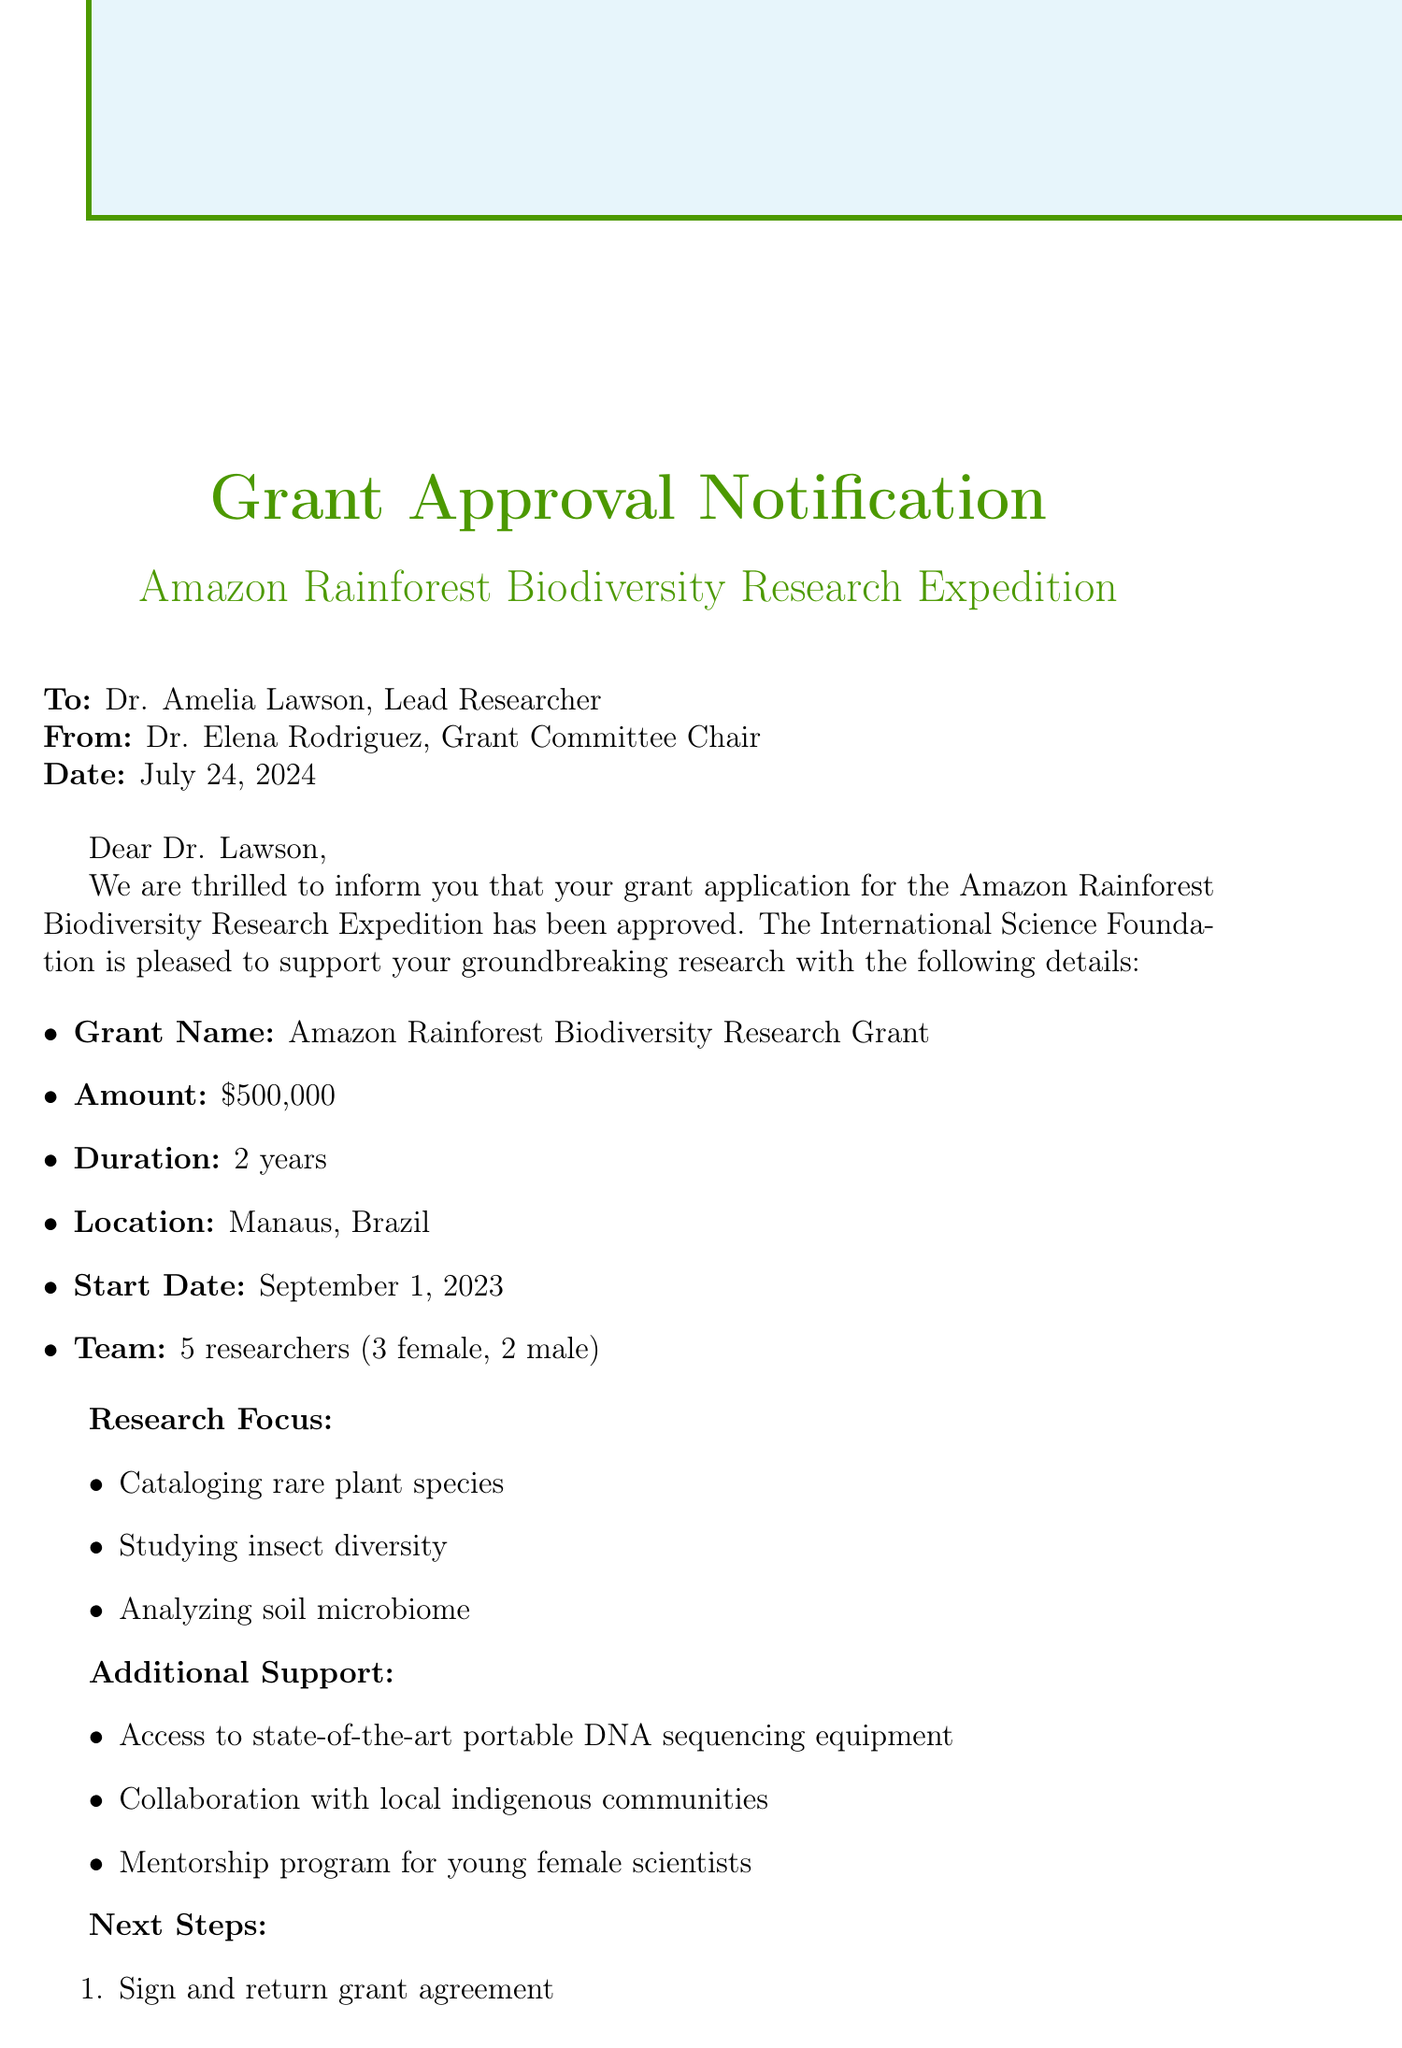What is the name of the grant? The grant is specifically referred to as the "Amazon Rainforest Biodiversity Research Grant" in the document.
Answer: Amazon Rainforest Biodiversity Research Grant What is the duration of the grant? The document indicates that the grant will last for "2 years."
Answer: 2 years Where is the expedition location? The document specifies that the expedition will take place in "Manaus, Brazil."
Answer: Manaus, Brazil How many researchers are on the team? The document states that the team is composed of "5 researchers."
Answer: 5 researchers What is one of the research focuses mentioned? The document lists three areas of focus, one being "Cataloging rare plant species."
Answer: Cataloging rare plant species Who is the sender of the notification? The sender is identified as "Dr. Elena Rodriguez" in the document.
Answer: Dr. Elena Rodriguez What is an expected outcome of the research? The document mentions that one expected outcome is a "Publication in leading scientific journals."
Answer: Publication in leading scientific journals Which type of program is included to support female scientists? The document highlights a "Mentorship program for young female scientists" as a form of additional support.
Answer: Mentorship program for young female scientists What is the next step after receiving the grant notification? According to the document, the first next step is to "Sign and return grant agreement."
Answer: Sign and return grant agreement 